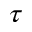Convert formula to latex. <formula><loc_0><loc_0><loc_500><loc_500>\tau</formula> 